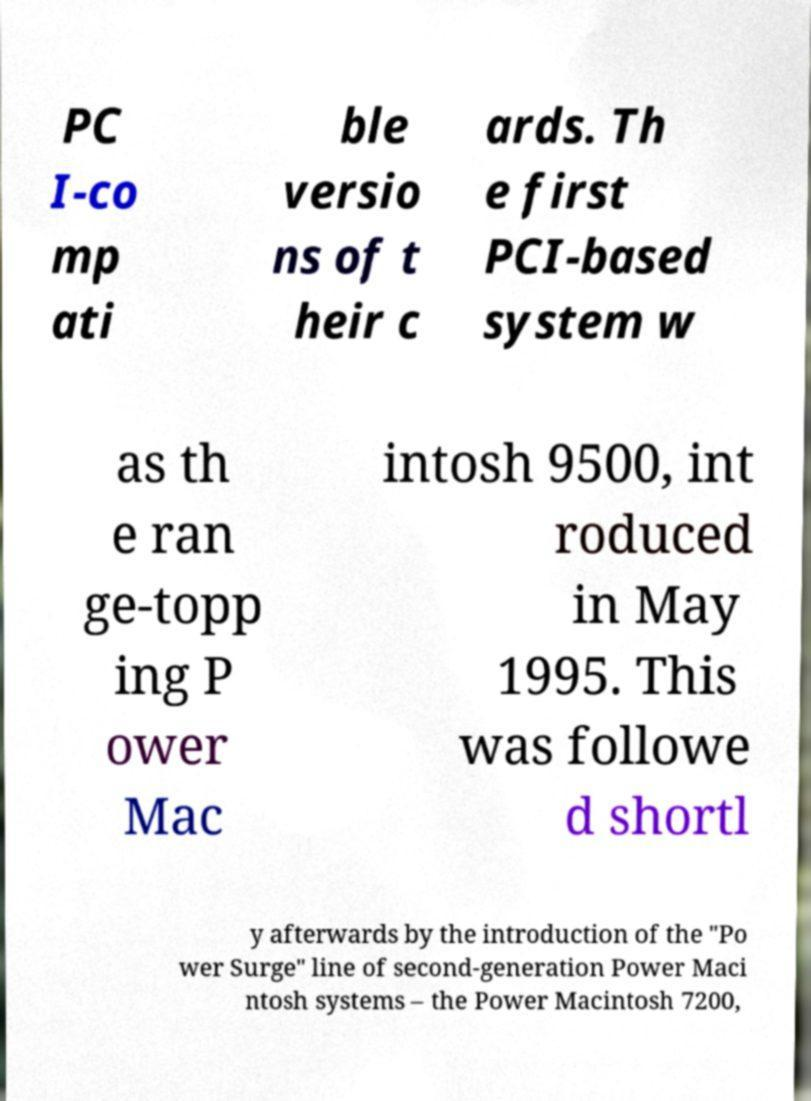For documentation purposes, I need the text within this image transcribed. Could you provide that? PC I-co mp ati ble versio ns of t heir c ards. Th e first PCI-based system w as th e ran ge-topp ing P ower Mac intosh 9500, int roduced in May 1995. This was followe d shortl y afterwards by the introduction of the "Po wer Surge" line of second-generation Power Maci ntosh systems – the Power Macintosh 7200, 